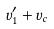<formula> <loc_0><loc_0><loc_500><loc_500>v _ { 1 } ^ { \prime } + v _ { c }</formula> 